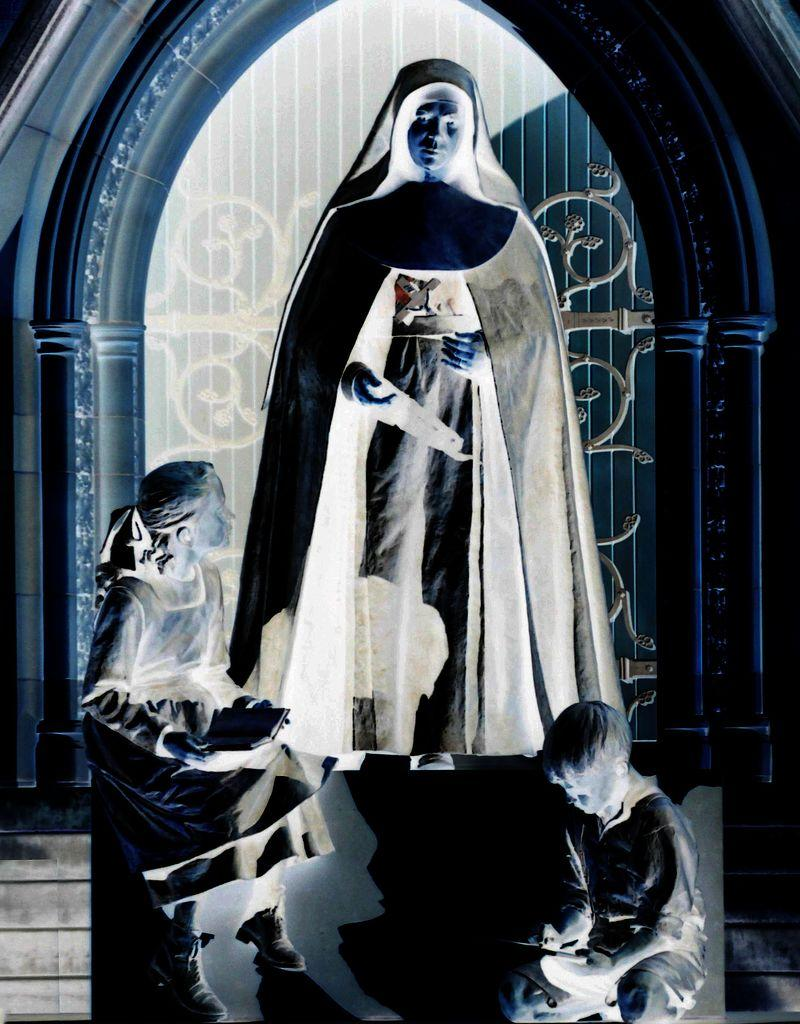What is the woman doing in the image? The woman is standing in the image. What are the children doing in the image? The children are sitting in the image and holding objects in their hands. What can be seen in the background of the image? There are stairs and other objects visible in the background of the image. What day of the week is it in the image? The day of the week is not mentioned or visible in the image. Can you see any spacecraft or astronauts in the image? There are no spacecraft or astronauts present in the image. 